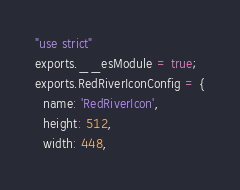<code> <loc_0><loc_0><loc_500><loc_500><_JavaScript_>"use strict"
exports.__esModule = true;
exports.RedRiverIconConfig = {
  name: 'RedRiverIcon',
  height: 512,
  width: 448,</code> 